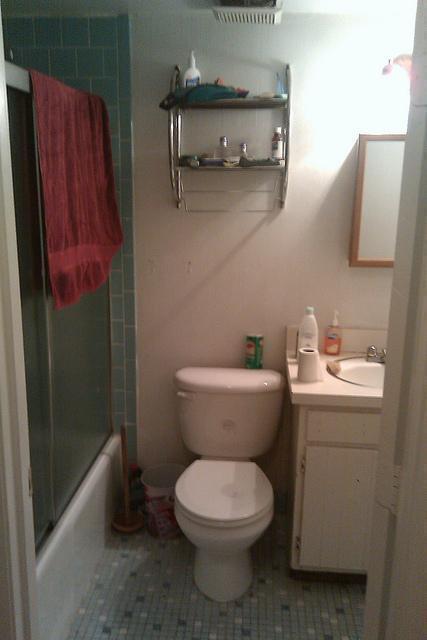What is in the container on the toilet tank?
Select the accurate answer and provide justification: `Answer: choice
Rationale: srationale.`
Options: Baby powder, toothpaste, bubble bath, cleanser. Answer: cleanser.
Rationale: There is a can of cleaner on top of the toilet. 